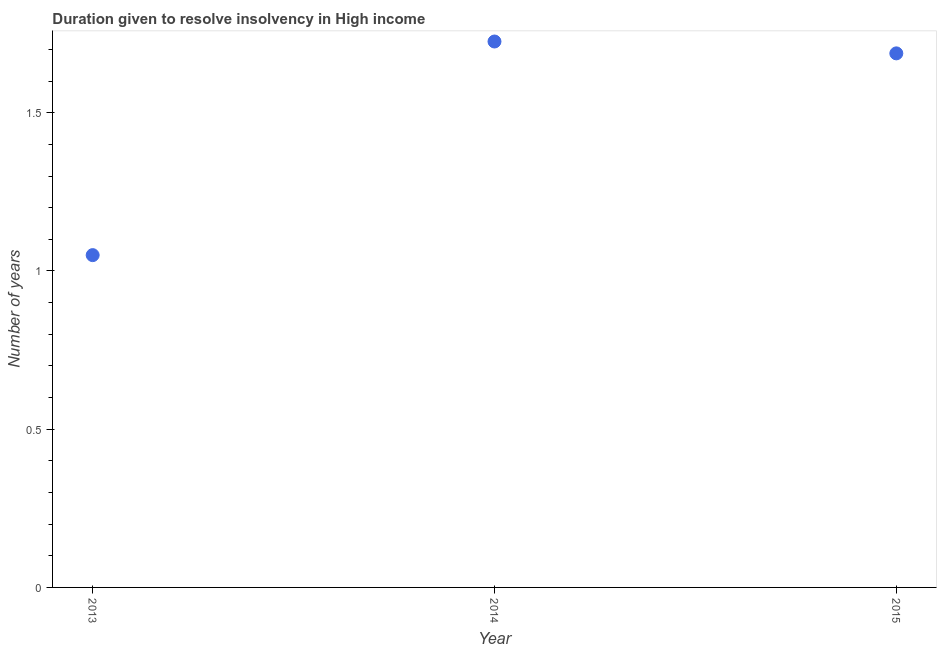What is the number of years to resolve insolvency in 2015?
Keep it short and to the point. 1.69. Across all years, what is the maximum number of years to resolve insolvency?
Offer a terse response. 1.73. Across all years, what is the minimum number of years to resolve insolvency?
Provide a short and direct response. 1.05. In which year was the number of years to resolve insolvency maximum?
Provide a succinct answer. 2014. In which year was the number of years to resolve insolvency minimum?
Ensure brevity in your answer.  2013. What is the sum of the number of years to resolve insolvency?
Offer a terse response. 4.46. What is the difference between the number of years to resolve insolvency in 2013 and 2015?
Offer a very short reply. -0.64. What is the average number of years to resolve insolvency per year?
Provide a short and direct response. 1.49. What is the median number of years to resolve insolvency?
Offer a terse response. 1.69. What is the ratio of the number of years to resolve insolvency in 2014 to that in 2015?
Keep it short and to the point. 1.02. Is the number of years to resolve insolvency in 2014 less than that in 2015?
Keep it short and to the point. No. What is the difference between the highest and the second highest number of years to resolve insolvency?
Make the answer very short. 0.04. What is the difference between the highest and the lowest number of years to resolve insolvency?
Give a very brief answer. 0.68. Does the number of years to resolve insolvency monotonically increase over the years?
Offer a terse response. No. How many dotlines are there?
Your answer should be compact. 1. Are the values on the major ticks of Y-axis written in scientific E-notation?
Your answer should be very brief. No. Does the graph contain any zero values?
Ensure brevity in your answer.  No. What is the title of the graph?
Offer a very short reply. Duration given to resolve insolvency in High income. What is the label or title of the Y-axis?
Offer a terse response. Number of years. What is the Number of years in 2014?
Keep it short and to the point. 1.73. What is the Number of years in 2015?
Ensure brevity in your answer.  1.69. What is the difference between the Number of years in 2013 and 2014?
Offer a terse response. -0.68. What is the difference between the Number of years in 2013 and 2015?
Offer a terse response. -0.64. What is the difference between the Number of years in 2014 and 2015?
Provide a succinct answer. 0.04. What is the ratio of the Number of years in 2013 to that in 2014?
Give a very brief answer. 0.61. What is the ratio of the Number of years in 2013 to that in 2015?
Your answer should be compact. 0.62. What is the ratio of the Number of years in 2014 to that in 2015?
Provide a short and direct response. 1.02. 